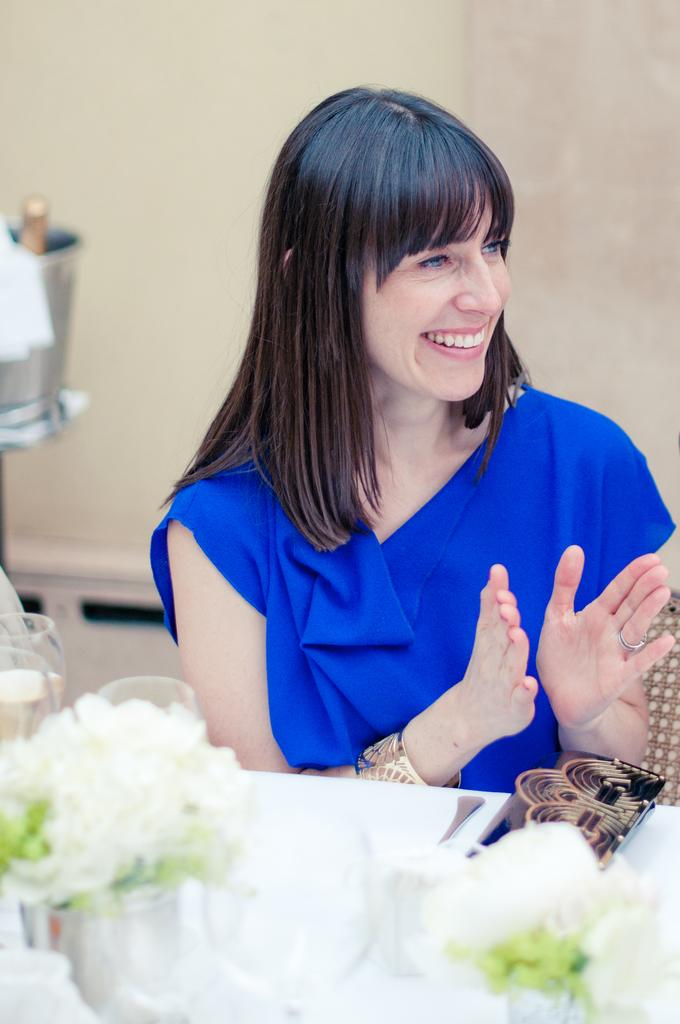Who is present in the image? There is a woman in the image. What is the woman doing in the image? The woman is sitting and smiling. What can be seen on the table in the image? There is a flower, a glass, and a pouch on the table. What type of business is the woman conducting in the image? There is no indication of any business activity in the image. The woman is simply sitting and smiling. 